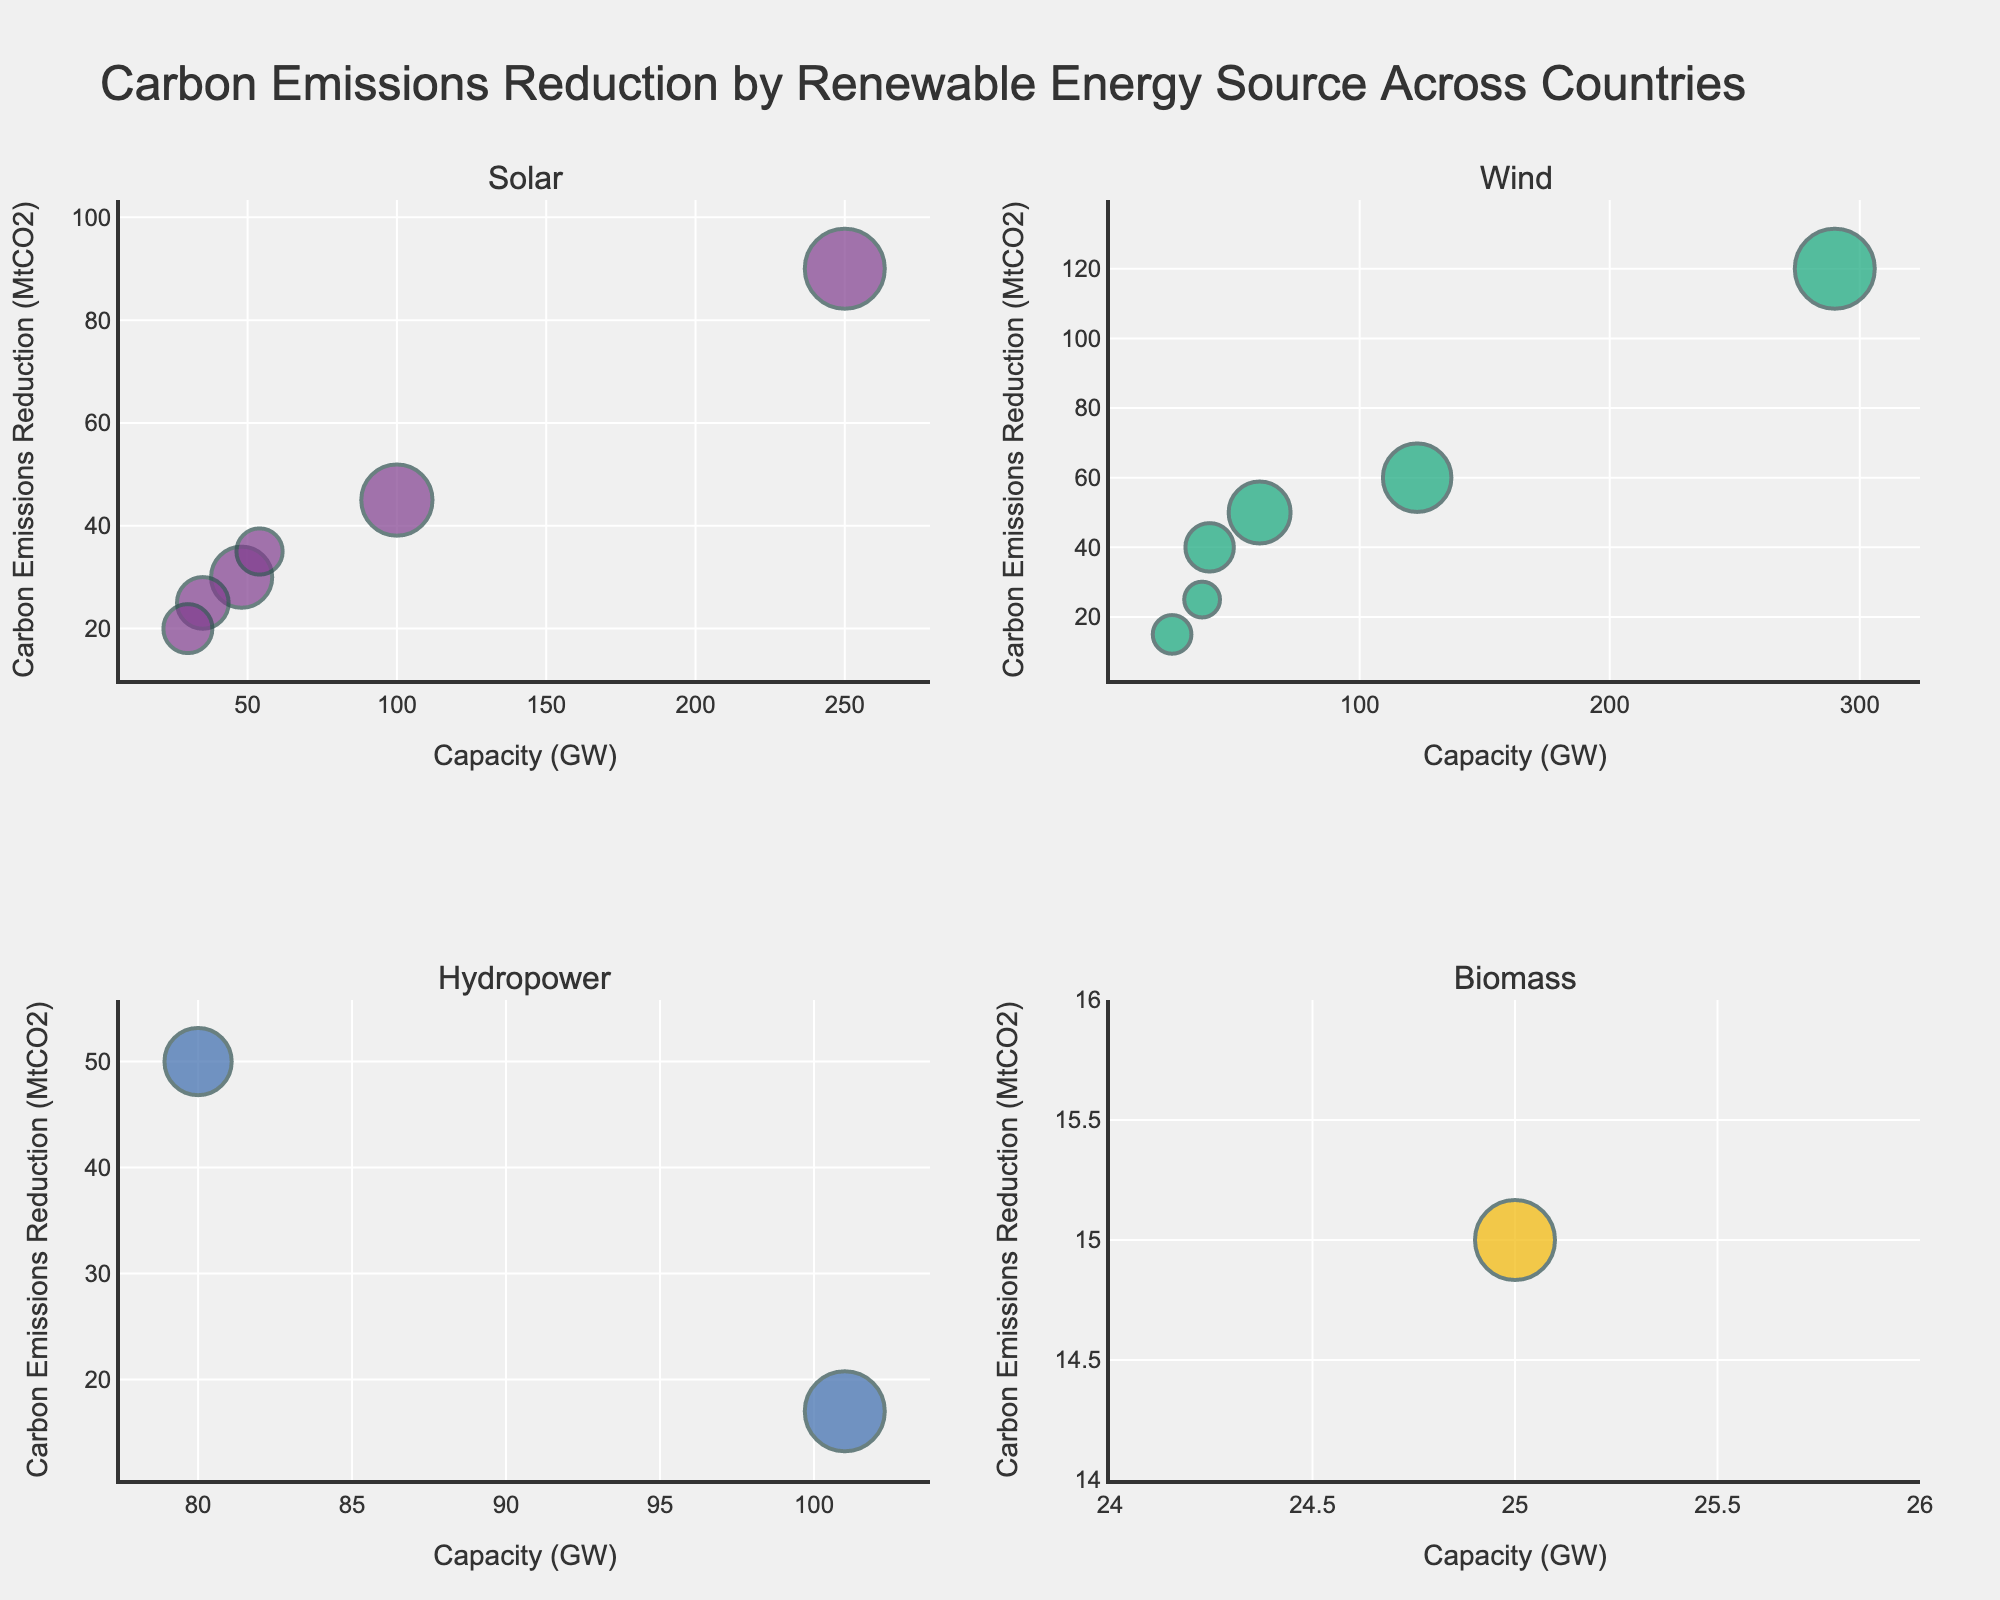What is the title of the figure? The title of the figure is typically displayed at the top and is often larger or bolder than other text. Here, the title is "Carbon Emissions Reduction by Renewable Energy Source Across Countries".
Answer: Carbon Emissions Reduction by Renewable Energy Source Across Countries Which country has the highest carbon emissions reduction in the Wind category? By looking at the bubbles in the Wind subplot, the largest y-value represents carbon emissions reduction. Here, the highest carbon emissions reduction for Wind is in China.
Answer: China What are the axis titles for all subplots? The x-axis title is "Capacity (GW)" and the y-axis title is "Carbon Emissions Reduction (MtCO2)", as seen from the labels on each axis.
Answer: Capacity (GW), Carbon Emissions Reduction (MtCO2) How many renewable energy sources are displayed in the subplots? The subplot titles indicate the number of renewable energy sources. The titles are 'Solar', 'Wind', 'Hydropower', and 'Biomass'.
Answer: 4 Which country invested the most in Solar energy? By looking at the bubble size in the Solar subplot, the largest bubble represents the highest investment. This is seen in the United States.
Answer: United States What is the total carbon emissions reduction of Solar energy in India? From the Solar subplot, locate the bubble for India and read the y-value. It shows a reduction of 35 MtCO2.
Answer: 35 MtCO2 How does the carbon emissions reduction for Hydropower in Brazil compare to the United States? In the Hydropower subplot, locate the bubbles for Brazil and the United States and compare their y-values. Brazil has a higher carbon emissions reduction (50 MtCO2) than the United States (17 MtCO2).
Answer: Brazil has higher Which countries are represented in the Biomass subplot? The Biomass subplot contains bubbles labeled "Brazil", indicating that only Brazil is represented in this subplot.
Answer: Brazil In the Wind category, which country has the least capacity? By looking at the x-values in the Wind subplot, the smallest x-value represents the least capacity, found in the United Kingdom.
Answer: United Kingdom What is the approximate investment in Wind energy by Germany? In the Wind subplot, locate Germany's bubble. The hover text can aid in obtaining the exact investment, which is approximately $90 Billion.
Answer: $90 Billion 